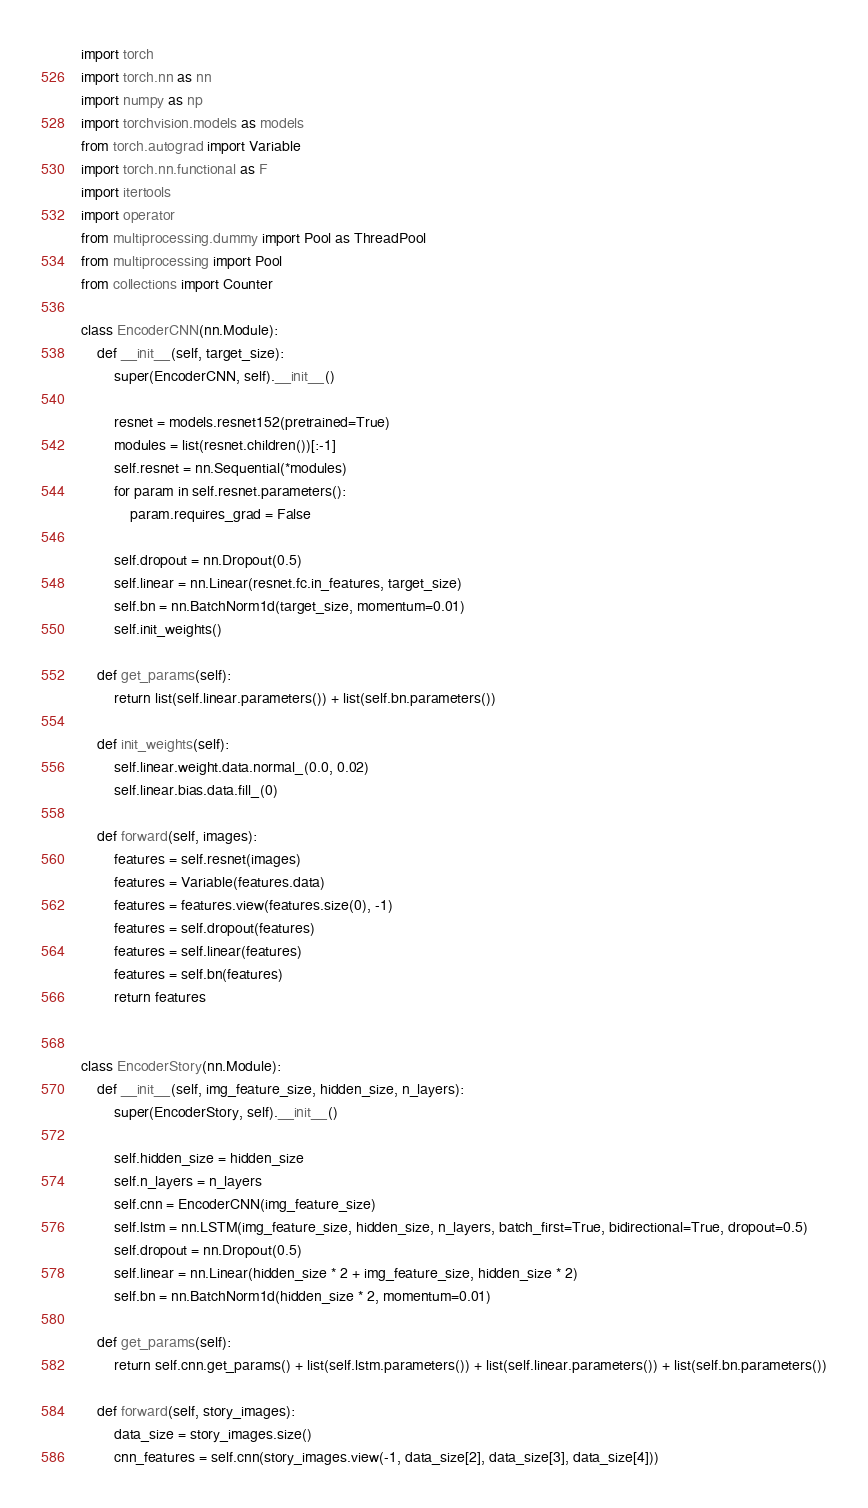<code> <loc_0><loc_0><loc_500><loc_500><_Python_>import torch
import torch.nn as nn
import numpy as np
import torchvision.models as models
from torch.autograd import Variable
import torch.nn.functional as F
import itertools
import operator
from multiprocessing.dummy import Pool as ThreadPool
from multiprocessing import Pool
from collections import Counter

class EncoderCNN(nn.Module):
    def __init__(self, target_size):
        super(EncoderCNN, self).__init__()

        resnet = models.resnet152(pretrained=True)
        modules = list(resnet.children())[:-1]
        self.resnet = nn.Sequential(*modules)
        for param in self.resnet.parameters():
            param.requires_grad = False

        self.dropout = nn.Dropout(0.5)
        self.linear = nn.Linear(resnet.fc.in_features, target_size)
        self.bn = nn.BatchNorm1d(target_size, momentum=0.01)
        self.init_weights()

    def get_params(self):
        return list(self.linear.parameters()) + list(self.bn.parameters())

    def init_weights(self):
        self.linear.weight.data.normal_(0.0, 0.02)
        self.linear.bias.data.fill_(0)

    def forward(self, images):
        features = self.resnet(images)
        features = Variable(features.data)
        features = features.view(features.size(0), -1)
        features = self.dropout(features)
        features = self.linear(features)
        features = self.bn(features)
        return features


class EncoderStory(nn.Module):
    def __init__(self, img_feature_size, hidden_size, n_layers):
        super(EncoderStory, self).__init__()

        self.hidden_size = hidden_size
        self.n_layers = n_layers
        self.cnn = EncoderCNN(img_feature_size)
        self.lstm = nn.LSTM(img_feature_size, hidden_size, n_layers, batch_first=True, bidirectional=True, dropout=0.5)
        self.dropout = nn.Dropout(0.5)
        self.linear = nn.Linear(hidden_size * 2 + img_feature_size, hidden_size * 2)
        self.bn = nn.BatchNorm1d(hidden_size * 2, momentum=0.01)

    def get_params(self):
        return self.cnn.get_params() + list(self.lstm.parameters()) + list(self.linear.parameters()) + list(self.bn.parameters())

    def forward(self, story_images):
        data_size = story_images.size()
        cnn_features = self.cnn(story_images.view(-1, data_size[2], data_size[3], data_size[4]))</code> 